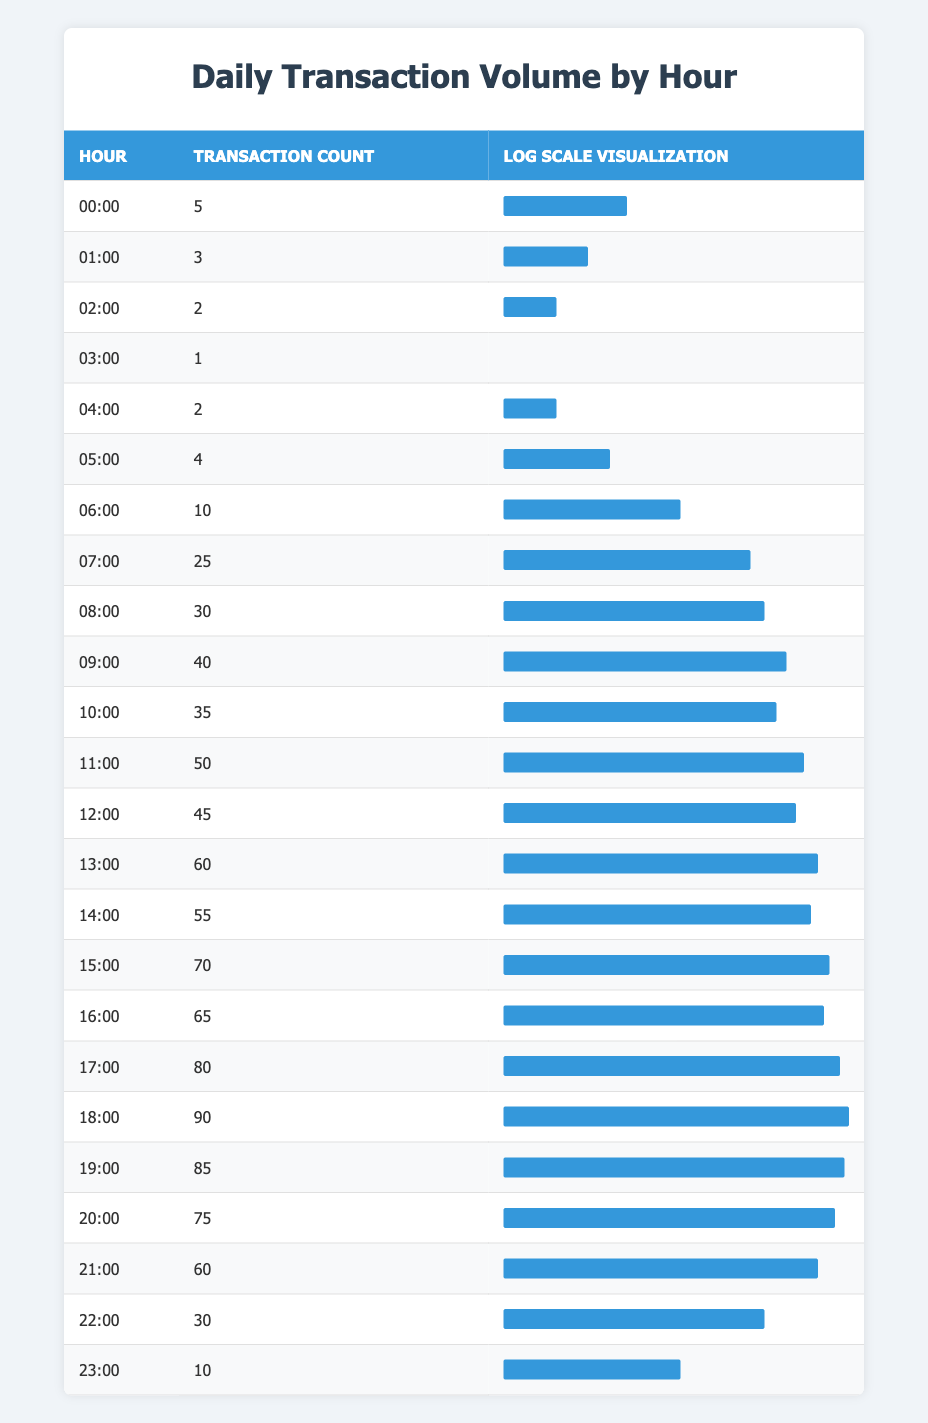What is the transaction count at 12:00? According to the table, the transaction count at 12:00 is listed directly.
Answer: 45 What hour recorded the highest transaction count? By examining the 'Transaction Count' column, I can see that the highest transaction count is at 18:00 with a count of 90.
Answer: 18:00 What is the average transaction count from 00:00 to 06:00? The transaction counts from 00:00 to 06:00 are 5, 3, 2, 1, 2, and 10. Summing these gives 5 + 3 + 2 + 1 + 2 + 10 = 23. There are 6 hours, so the average is 23/6 = 3.83.
Answer: 3.83 Did more transactions occur during the day than at night? "Day" hours can be considered from 06:00 to 18:00, and "night" hours from 00:00 to 05:00 and 19:00 to 23:00. Summing the day activities gives 10 + 25 + 30 + 40 + 35 + 50 + 45 + 60 + 55 + 70 + 65 + 80 + 90 =  675. The night count is 5 + 3 + 2 + 1 + 2 + 4 + 85 + 75 + 60 + 30 + 10 =  305. Since 675 > 305, more transactions occurred during the day.
Answer: Yes What is the difference in transaction counts between 10:00 and 16:00? The transaction count at 10:00 is 35, and the count at 16:00 is 65. The difference is 65 - 35 = 30.
Answer: 30 Which hour saw a transaction count of 70? Checking the table, I can clearly see that the transaction count of 70 occurs at 15:00.
Answer: 15:00 What is the total transaction count for the hours from 19:00 to 23:00? The transaction counts for these hours are 85, 75, 60, 30, and 10. Adding these: 85 + 75 + 60 + 30 + 10 = 260.
Answer: 260 Is the transaction count during 17:00 higher than that in 11:00? The transaction count at 17:00 is 80, and at 11:00 it is 50. Since 80 > 50, the statement is true.
Answer: Yes What hour has the lowest transaction count? Scanning the 'Transaction Count' column, the lowest count is 1, which occurs at 03:00.
Answer: 03:00 